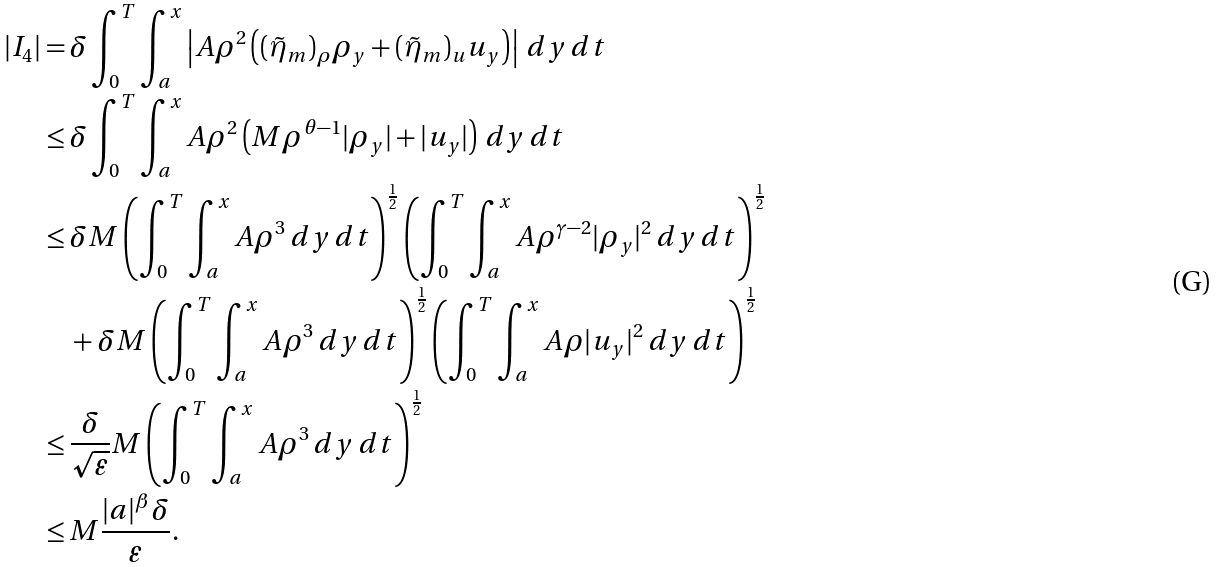Convert formula to latex. <formula><loc_0><loc_0><loc_500><loc_500>| I _ { 4 } | = & \, \delta \int _ { 0 } ^ { T } \int _ { a } ^ { x } \left | A \rho ^ { 2 } \left ( ( \tilde { \eta } _ { m } ) _ { \rho } \rho _ { y } + ( \tilde { \eta } _ { m } ) _ { u } u _ { y } \right ) \right | \, d y \, d t \\ \leq & \, \delta \int _ { 0 } ^ { T } \int _ { a } ^ { x } A \rho ^ { 2 } \left ( M \rho ^ { \theta - 1 } | \rho _ { y } | + | u _ { y } | \right ) \, d y \, d t \\ \leq & \, \delta M \left ( \int _ { 0 } ^ { T } \int _ { a } ^ { x } A \rho ^ { 3 } \, d y \, d t \right ) ^ { \frac { 1 } { 2 } } \left ( \int _ { 0 } ^ { T } \int _ { a } ^ { x } A \rho ^ { \gamma - 2 } | \rho _ { y } | ^ { 2 } \, d y \, d t \right ) ^ { \frac { 1 } { 2 } } \\ & \, + \delta M \left ( \int _ { 0 } ^ { T } \int _ { a } ^ { x } A \rho ^ { 3 } \, d y \, d t \right ) ^ { \frac { 1 } { 2 } } \left ( \int _ { 0 } ^ { T } \int _ { a } ^ { x } A \rho | u _ { y } | ^ { 2 } \, d y \, d t \right ) ^ { \frac { 1 } { 2 } } \\ \leq & \, \frac { \delta } { \sqrt { \varepsilon } } M \left ( \int _ { 0 } ^ { T } \int _ { a } ^ { x } A \rho ^ { 3 } \, d y \, d t \right ) ^ { \frac { 1 } { 2 } } \\ \leq & \, M \frac { | a | ^ { \beta } \delta } { \varepsilon } .</formula> 